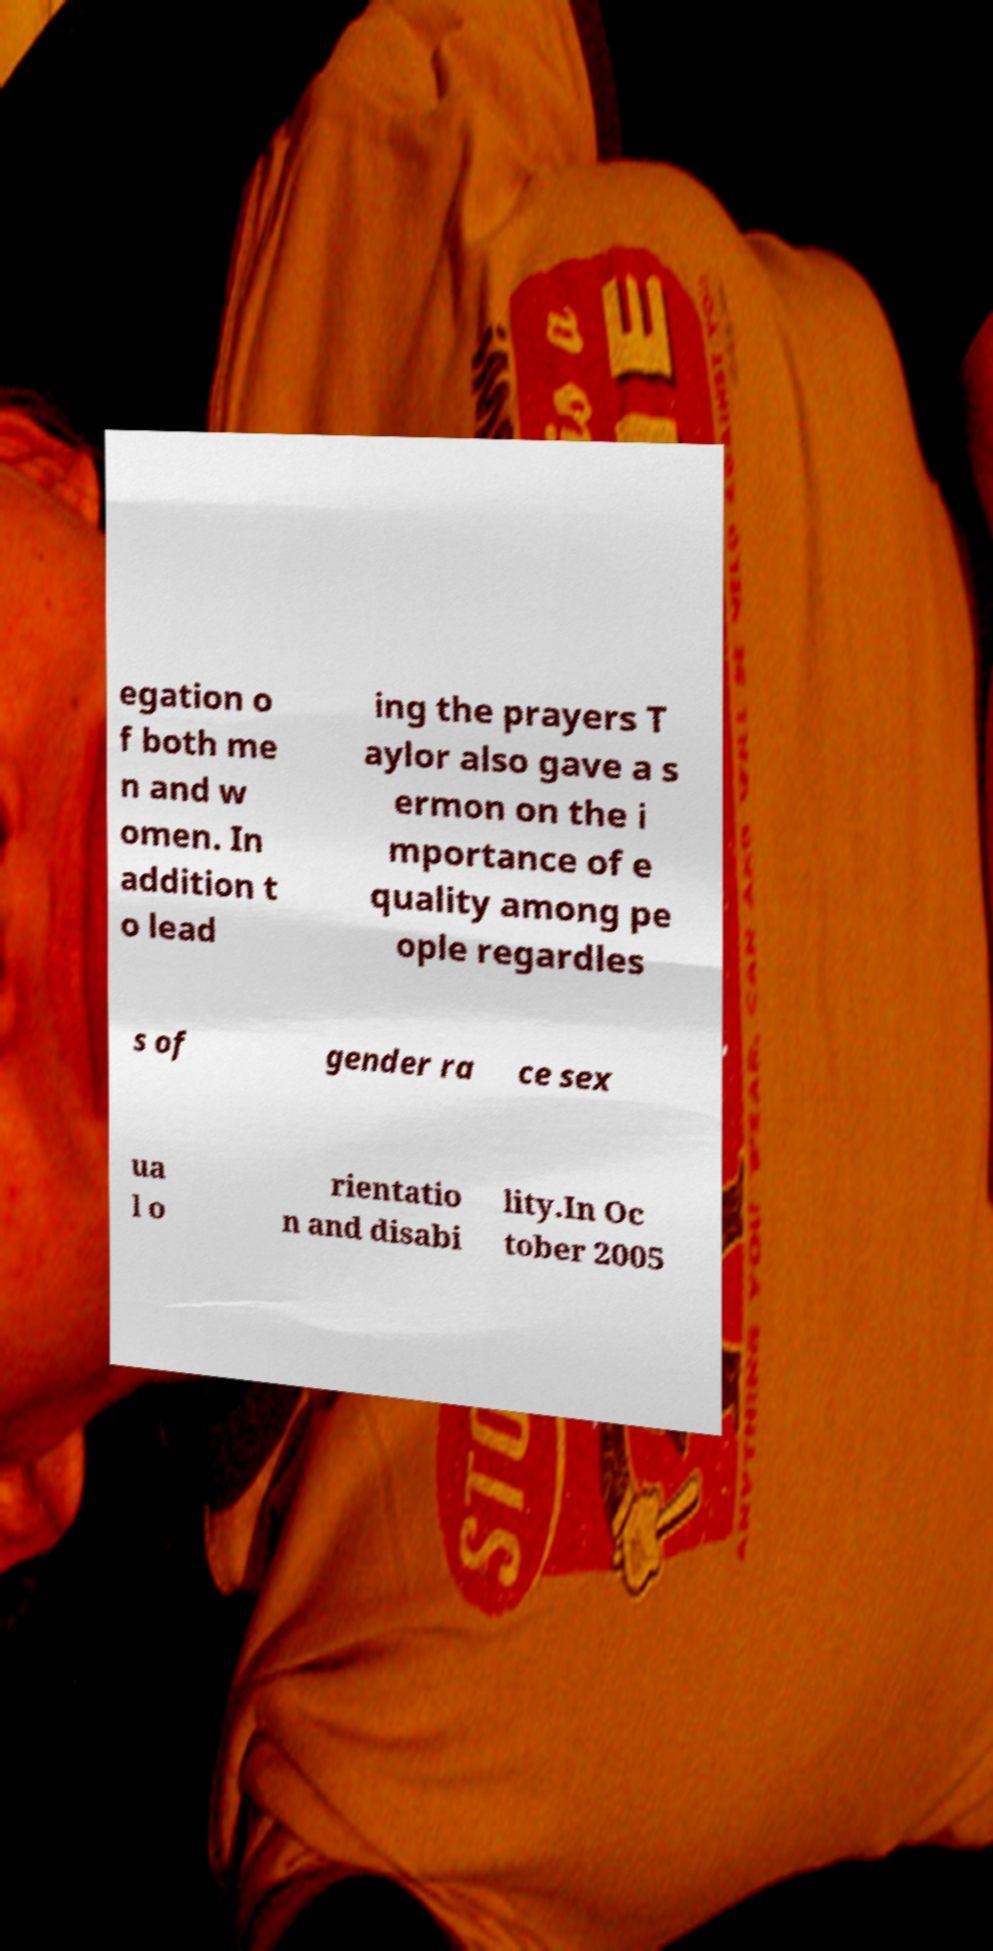Please read and relay the text visible in this image. What does it say? egation o f both me n and w omen. In addition t o lead ing the prayers T aylor also gave a s ermon on the i mportance of e quality among pe ople regardles s of gender ra ce sex ua l o rientatio n and disabi lity.In Oc tober 2005 